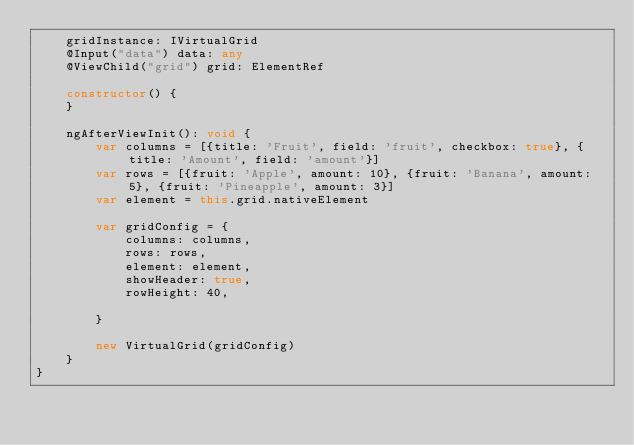Convert code to text. <code><loc_0><loc_0><loc_500><loc_500><_TypeScript_>    gridInstance: IVirtualGrid
    @Input("data") data: any
    @ViewChild("grid") grid: ElementRef

    constructor() {
    }

    ngAfterViewInit(): void {
        var columns = [{title: 'Fruit', field: 'fruit', checkbox: true}, {title: 'Amount', field: 'amount'}]
        var rows = [{fruit: 'Apple', amount: 10}, {fruit: 'Banana', amount: 5}, {fruit: 'Pineapple', amount: 3}]
        var element = this.grid.nativeElement

        var gridConfig = {
            columns: columns,
            rows: rows,
            element: element,
            showHeader: true,
            rowHeight: 40,

        }

        new VirtualGrid(gridConfig)
    }
}
</code> 